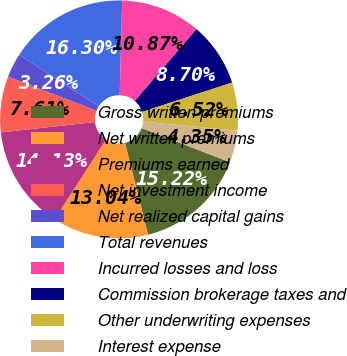Convert chart. <chart><loc_0><loc_0><loc_500><loc_500><pie_chart><fcel>Gross written premiums<fcel>Net written premiums<fcel>Premiums earned<fcel>Net investment income<fcel>Net realized capital gains<fcel>Total revenues<fcel>Incurred losses and loss<fcel>Commission brokerage taxes and<fcel>Other underwriting expenses<fcel>Interest expense<nl><fcel>15.22%<fcel>13.04%<fcel>14.13%<fcel>7.61%<fcel>3.26%<fcel>16.3%<fcel>10.87%<fcel>8.7%<fcel>6.52%<fcel>4.35%<nl></chart> 